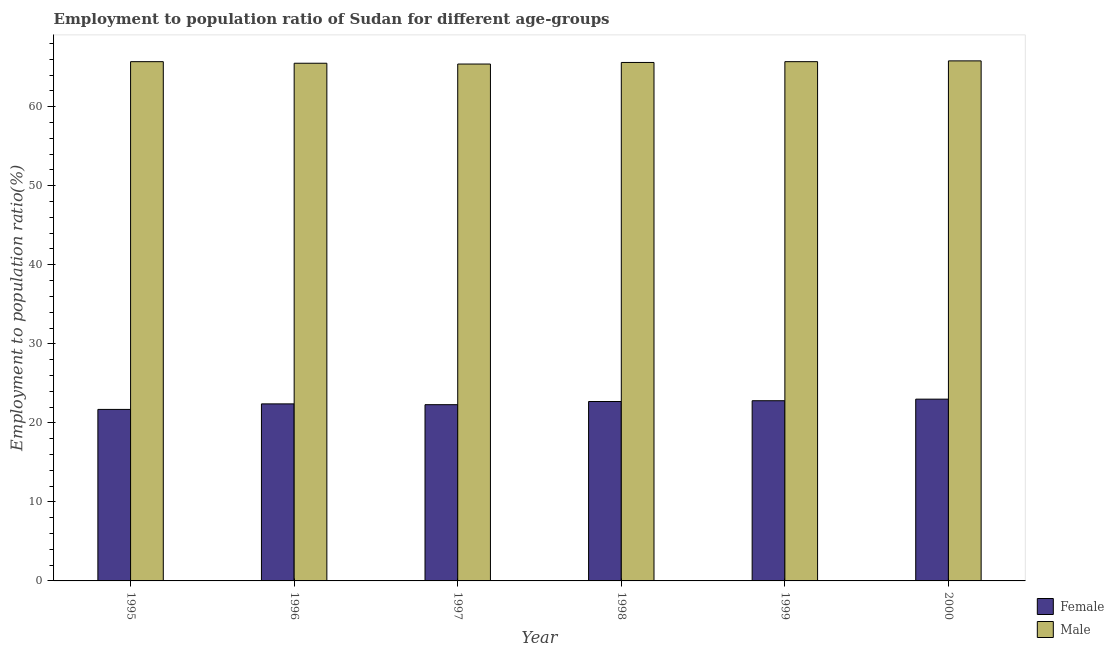Are the number of bars per tick equal to the number of legend labels?
Give a very brief answer. Yes. Are the number of bars on each tick of the X-axis equal?
Offer a very short reply. Yes. How many bars are there on the 4th tick from the left?
Make the answer very short. 2. How many bars are there on the 1st tick from the right?
Your response must be concise. 2. What is the label of the 4th group of bars from the left?
Your answer should be very brief. 1998. What is the employment to population ratio(female) in 1999?
Your response must be concise. 22.8. Across all years, what is the minimum employment to population ratio(male)?
Provide a short and direct response. 65.4. In which year was the employment to population ratio(male) minimum?
Your response must be concise. 1997. What is the total employment to population ratio(male) in the graph?
Keep it short and to the point. 393.7. What is the difference between the employment to population ratio(female) in 1996 and that in 1999?
Provide a short and direct response. -0.4. What is the difference between the employment to population ratio(male) in 1997 and the employment to population ratio(female) in 1995?
Give a very brief answer. -0.3. What is the average employment to population ratio(female) per year?
Offer a very short reply. 22.48. What is the ratio of the employment to population ratio(female) in 1996 to that in 2000?
Provide a short and direct response. 0.97. Is the difference between the employment to population ratio(female) in 1998 and 1999 greater than the difference between the employment to population ratio(male) in 1998 and 1999?
Ensure brevity in your answer.  No. What is the difference between the highest and the second highest employment to population ratio(male)?
Your response must be concise. 0.1. What is the difference between the highest and the lowest employment to population ratio(female)?
Your response must be concise. 1.3. In how many years, is the employment to population ratio(female) greater than the average employment to population ratio(female) taken over all years?
Give a very brief answer. 3. Is the sum of the employment to population ratio(male) in 1995 and 1997 greater than the maximum employment to population ratio(female) across all years?
Offer a very short reply. Yes. What does the 1st bar from the left in 1997 represents?
Your response must be concise. Female. What does the 2nd bar from the right in 1999 represents?
Provide a succinct answer. Female. Are all the bars in the graph horizontal?
Provide a succinct answer. No. What is the difference between two consecutive major ticks on the Y-axis?
Your answer should be very brief. 10. Are the values on the major ticks of Y-axis written in scientific E-notation?
Offer a very short reply. No. Does the graph contain any zero values?
Your response must be concise. No. Where does the legend appear in the graph?
Give a very brief answer. Bottom right. How are the legend labels stacked?
Ensure brevity in your answer.  Vertical. What is the title of the graph?
Provide a short and direct response. Employment to population ratio of Sudan for different age-groups. What is the label or title of the Y-axis?
Provide a short and direct response. Employment to population ratio(%). What is the Employment to population ratio(%) in Female in 1995?
Offer a very short reply. 21.7. What is the Employment to population ratio(%) of Male in 1995?
Your answer should be very brief. 65.7. What is the Employment to population ratio(%) of Female in 1996?
Offer a very short reply. 22.4. What is the Employment to population ratio(%) in Male in 1996?
Your answer should be compact. 65.5. What is the Employment to population ratio(%) in Female in 1997?
Offer a very short reply. 22.3. What is the Employment to population ratio(%) of Male in 1997?
Your answer should be compact. 65.4. What is the Employment to population ratio(%) of Female in 1998?
Your answer should be very brief. 22.7. What is the Employment to population ratio(%) in Male in 1998?
Offer a terse response. 65.6. What is the Employment to population ratio(%) of Female in 1999?
Make the answer very short. 22.8. What is the Employment to population ratio(%) in Male in 1999?
Your response must be concise. 65.7. What is the Employment to population ratio(%) of Male in 2000?
Keep it short and to the point. 65.8. Across all years, what is the maximum Employment to population ratio(%) of Male?
Keep it short and to the point. 65.8. Across all years, what is the minimum Employment to population ratio(%) of Female?
Give a very brief answer. 21.7. Across all years, what is the minimum Employment to population ratio(%) in Male?
Offer a very short reply. 65.4. What is the total Employment to population ratio(%) of Female in the graph?
Give a very brief answer. 134.9. What is the total Employment to population ratio(%) in Male in the graph?
Provide a short and direct response. 393.7. What is the difference between the Employment to population ratio(%) in Female in 1995 and that in 1996?
Offer a very short reply. -0.7. What is the difference between the Employment to population ratio(%) in Male in 1995 and that in 1996?
Offer a very short reply. 0.2. What is the difference between the Employment to population ratio(%) in Female in 1995 and that in 1997?
Your answer should be compact. -0.6. What is the difference between the Employment to population ratio(%) in Male in 1995 and that in 1998?
Keep it short and to the point. 0.1. What is the difference between the Employment to population ratio(%) in Male in 1995 and that in 1999?
Offer a terse response. 0. What is the difference between the Employment to population ratio(%) in Male in 1996 and that in 1997?
Offer a terse response. 0.1. What is the difference between the Employment to population ratio(%) in Female in 1996 and that in 1998?
Ensure brevity in your answer.  -0.3. What is the difference between the Employment to population ratio(%) of Male in 1996 and that in 1998?
Keep it short and to the point. -0.1. What is the difference between the Employment to population ratio(%) of Female in 1996 and that in 1999?
Your response must be concise. -0.4. What is the difference between the Employment to population ratio(%) of Male in 1996 and that in 1999?
Provide a succinct answer. -0.2. What is the difference between the Employment to population ratio(%) in Female in 1996 and that in 2000?
Offer a very short reply. -0.6. What is the difference between the Employment to population ratio(%) of Male in 1996 and that in 2000?
Keep it short and to the point. -0.3. What is the difference between the Employment to population ratio(%) of Female in 1997 and that in 1998?
Offer a very short reply. -0.4. What is the difference between the Employment to population ratio(%) in Male in 1997 and that in 1998?
Offer a terse response. -0.2. What is the difference between the Employment to population ratio(%) in Female in 1997 and that in 1999?
Your answer should be compact. -0.5. What is the difference between the Employment to population ratio(%) of Male in 1997 and that in 2000?
Provide a short and direct response. -0.4. What is the difference between the Employment to population ratio(%) of Male in 1998 and that in 2000?
Offer a very short reply. -0.2. What is the difference between the Employment to population ratio(%) of Female in 1995 and the Employment to population ratio(%) of Male in 1996?
Provide a short and direct response. -43.8. What is the difference between the Employment to population ratio(%) in Female in 1995 and the Employment to population ratio(%) in Male in 1997?
Offer a very short reply. -43.7. What is the difference between the Employment to population ratio(%) in Female in 1995 and the Employment to population ratio(%) in Male in 1998?
Make the answer very short. -43.9. What is the difference between the Employment to population ratio(%) of Female in 1995 and the Employment to population ratio(%) of Male in 1999?
Keep it short and to the point. -44. What is the difference between the Employment to population ratio(%) of Female in 1995 and the Employment to population ratio(%) of Male in 2000?
Offer a very short reply. -44.1. What is the difference between the Employment to population ratio(%) in Female in 1996 and the Employment to population ratio(%) in Male in 1997?
Your answer should be very brief. -43. What is the difference between the Employment to population ratio(%) of Female in 1996 and the Employment to population ratio(%) of Male in 1998?
Ensure brevity in your answer.  -43.2. What is the difference between the Employment to population ratio(%) in Female in 1996 and the Employment to population ratio(%) in Male in 1999?
Ensure brevity in your answer.  -43.3. What is the difference between the Employment to population ratio(%) in Female in 1996 and the Employment to population ratio(%) in Male in 2000?
Offer a terse response. -43.4. What is the difference between the Employment to population ratio(%) in Female in 1997 and the Employment to population ratio(%) in Male in 1998?
Your answer should be compact. -43.3. What is the difference between the Employment to population ratio(%) of Female in 1997 and the Employment to population ratio(%) of Male in 1999?
Your answer should be very brief. -43.4. What is the difference between the Employment to population ratio(%) of Female in 1997 and the Employment to population ratio(%) of Male in 2000?
Your response must be concise. -43.5. What is the difference between the Employment to population ratio(%) of Female in 1998 and the Employment to population ratio(%) of Male in 1999?
Your response must be concise. -43. What is the difference between the Employment to population ratio(%) in Female in 1998 and the Employment to population ratio(%) in Male in 2000?
Provide a succinct answer. -43.1. What is the difference between the Employment to population ratio(%) of Female in 1999 and the Employment to population ratio(%) of Male in 2000?
Ensure brevity in your answer.  -43. What is the average Employment to population ratio(%) in Female per year?
Your response must be concise. 22.48. What is the average Employment to population ratio(%) in Male per year?
Your answer should be very brief. 65.62. In the year 1995, what is the difference between the Employment to population ratio(%) of Female and Employment to population ratio(%) of Male?
Provide a short and direct response. -44. In the year 1996, what is the difference between the Employment to population ratio(%) of Female and Employment to population ratio(%) of Male?
Offer a terse response. -43.1. In the year 1997, what is the difference between the Employment to population ratio(%) in Female and Employment to population ratio(%) in Male?
Your response must be concise. -43.1. In the year 1998, what is the difference between the Employment to population ratio(%) in Female and Employment to population ratio(%) in Male?
Make the answer very short. -42.9. In the year 1999, what is the difference between the Employment to population ratio(%) in Female and Employment to population ratio(%) in Male?
Keep it short and to the point. -42.9. In the year 2000, what is the difference between the Employment to population ratio(%) of Female and Employment to population ratio(%) of Male?
Your answer should be very brief. -42.8. What is the ratio of the Employment to population ratio(%) of Female in 1995 to that in 1996?
Your answer should be compact. 0.97. What is the ratio of the Employment to population ratio(%) in Female in 1995 to that in 1997?
Ensure brevity in your answer.  0.97. What is the ratio of the Employment to population ratio(%) in Female in 1995 to that in 1998?
Ensure brevity in your answer.  0.96. What is the ratio of the Employment to population ratio(%) in Male in 1995 to that in 1998?
Provide a short and direct response. 1. What is the ratio of the Employment to population ratio(%) of Female in 1995 to that in 1999?
Keep it short and to the point. 0.95. What is the ratio of the Employment to population ratio(%) in Female in 1995 to that in 2000?
Offer a terse response. 0.94. What is the ratio of the Employment to population ratio(%) of Female in 1996 to that in 1999?
Your answer should be compact. 0.98. What is the ratio of the Employment to population ratio(%) of Male in 1996 to that in 1999?
Your answer should be very brief. 1. What is the ratio of the Employment to population ratio(%) of Female in 1996 to that in 2000?
Provide a short and direct response. 0.97. What is the ratio of the Employment to population ratio(%) in Female in 1997 to that in 1998?
Ensure brevity in your answer.  0.98. What is the ratio of the Employment to population ratio(%) in Male in 1997 to that in 1998?
Your answer should be compact. 1. What is the ratio of the Employment to population ratio(%) of Female in 1997 to that in 1999?
Make the answer very short. 0.98. What is the ratio of the Employment to population ratio(%) of Male in 1997 to that in 1999?
Offer a terse response. 1. What is the ratio of the Employment to population ratio(%) in Female in 1997 to that in 2000?
Give a very brief answer. 0.97. What is the ratio of the Employment to population ratio(%) of Male in 1997 to that in 2000?
Ensure brevity in your answer.  0.99. What is the ratio of the Employment to population ratio(%) in Male in 1998 to that in 1999?
Keep it short and to the point. 1. What is the ratio of the Employment to population ratio(%) of Female in 1999 to that in 2000?
Provide a succinct answer. 0.99. What is the difference between the highest and the second highest Employment to population ratio(%) in Male?
Make the answer very short. 0.1. 